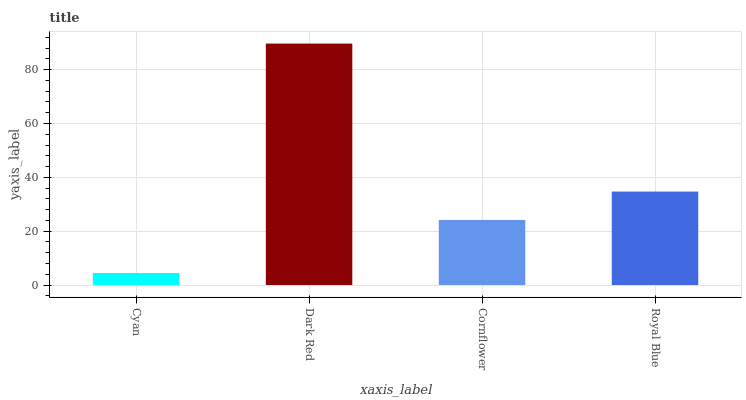Is Cyan the minimum?
Answer yes or no. Yes. Is Dark Red the maximum?
Answer yes or no. Yes. Is Cornflower the minimum?
Answer yes or no. No. Is Cornflower the maximum?
Answer yes or no. No. Is Dark Red greater than Cornflower?
Answer yes or no. Yes. Is Cornflower less than Dark Red?
Answer yes or no. Yes. Is Cornflower greater than Dark Red?
Answer yes or no. No. Is Dark Red less than Cornflower?
Answer yes or no. No. Is Royal Blue the high median?
Answer yes or no. Yes. Is Cornflower the low median?
Answer yes or no. Yes. Is Cornflower the high median?
Answer yes or no. No. Is Cyan the low median?
Answer yes or no. No. 